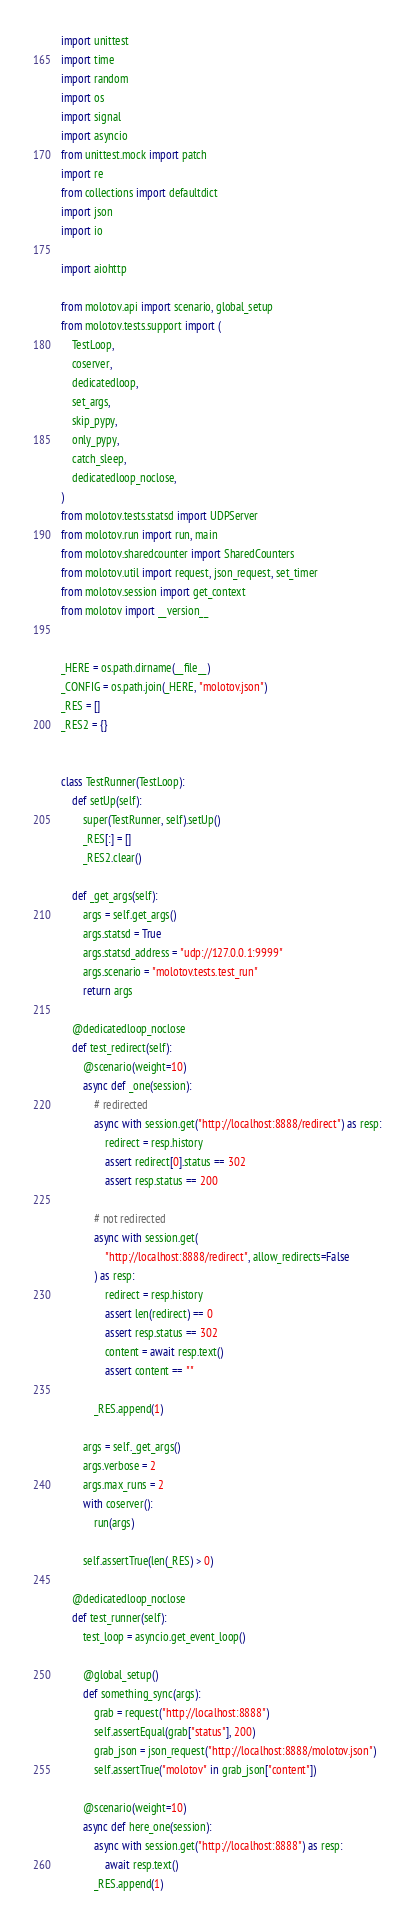<code> <loc_0><loc_0><loc_500><loc_500><_Python_>import unittest
import time
import random
import os
import signal
import asyncio
from unittest.mock import patch
import re
from collections import defaultdict
import json
import io

import aiohttp

from molotov.api import scenario, global_setup
from molotov.tests.support import (
    TestLoop,
    coserver,
    dedicatedloop,
    set_args,
    skip_pypy,
    only_pypy,
    catch_sleep,
    dedicatedloop_noclose,
)
from molotov.tests.statsd import UDPServer
from molotov.run import run, main
from molotov.sharedcounter import SharedCounters
from molotov.util import request, json_request, set_timer
from molotov.session import get_context
from molotov import __version__


_HERE = os.path.dirname(__file__)
_CONFIG = os.path.join(_HERE, "molotov.json")
_RES = []
_RES2 = {}


class TestRunner(TestLoop):
    def setUp(self):
        super(TestRunner, self).setUp()
        _RES[:] = []
        _RES2.clear()

    def _get_args(self):
        args = self.get_args()
        args.statsd = True
        args.statsd_address = "udp://127.0.0.1:9999"
        args.scenario = "molotov.tests.test_run"
        return args

    @dedicatedloop_noclose
    def test_redirect(self):
        @scenario(weight=10)
        async def _one(session):
            # redirected
            async with session.get("http://localhost:8888/redirect") as resp:
                redirect = resp.history
                assert redirect[0].status == 302
                assert resp.status == 200

            # not redirected
            async with session.get(
                "http://localhost:8888/redirect", allow_redirects=False
            ) as resp:
                redirect = resp.history
                assert len(redirect) == 0
                assert resp.status == 302
                content = await resp.text()
                assert content == ""

            _RES.append(1)

        args = self._get_args()
        args.verbose = 2
        args.max_runs = 2
        with coserver():
            run(args)

        self.assertTrue(len(_RES) > 0)

    @dedicatedloop_noclose
    def test_runner(self):
        test_loop = asyncio.get_event_loop()

        @global_setup()
        def something_sync(args):
            grab = request("http://localhost:8888")
            self.assertEqual(grab["status"], 200)
            grab_json = json_request("http://localhost:8888/molotov.json")
            self.assertTrue("molotov" in grab_json["content"])

        @scenario(weight=10)
        async def here_one(session):
            async with session.get("http://localhost:8888") as resp:
                await resp.text()
            _RES.append(1)
</code> 